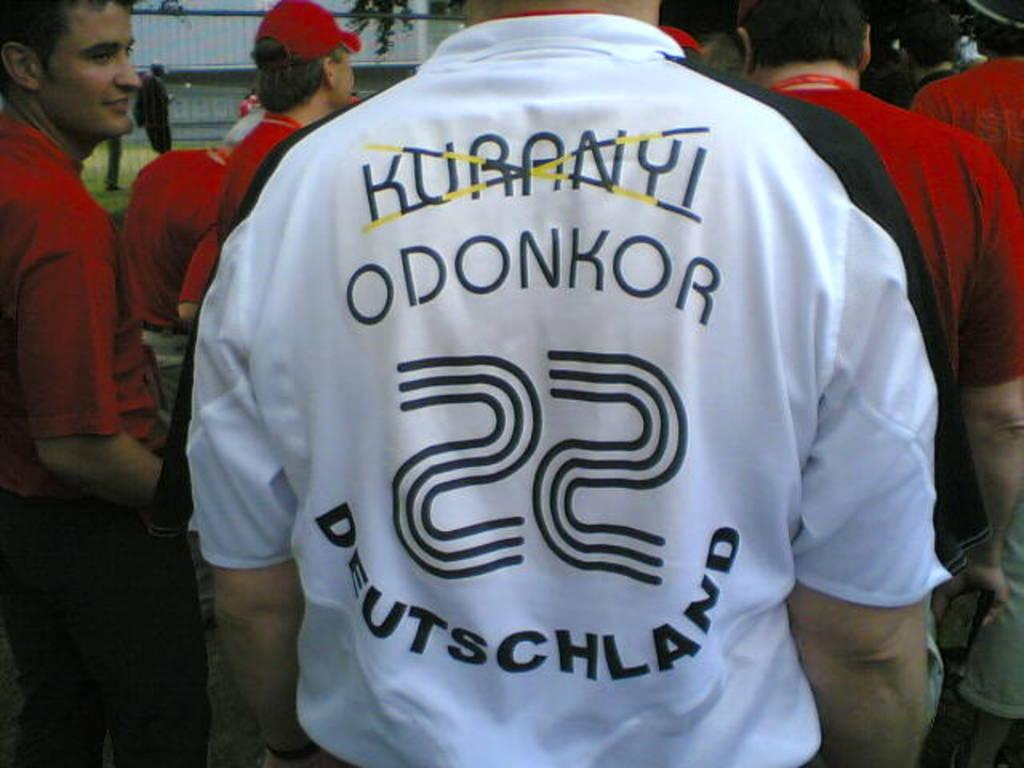Provide a one-sentence caption for the provided image. A man is wearing a white shirt with Deutschland written across the back. 